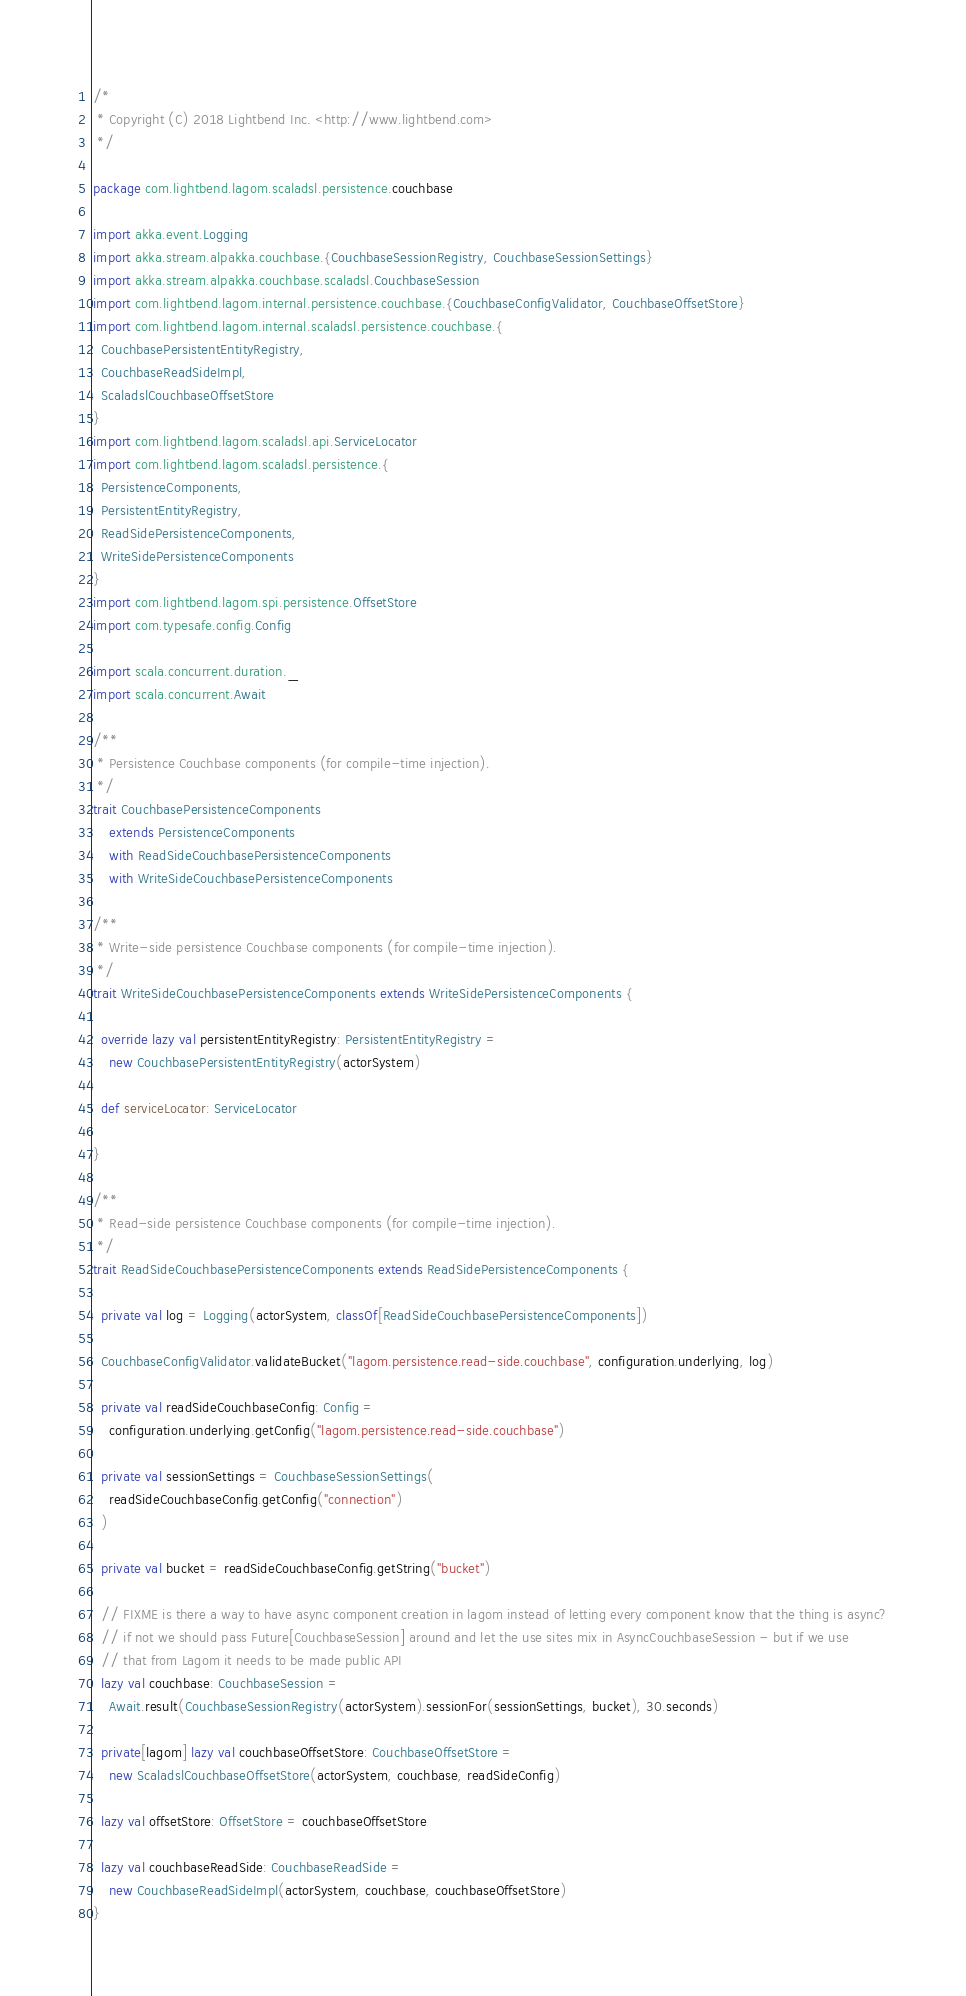Convert code to text. <code><loc_0><loc_0><loc_500><loc_500><_Scala_>/*
 * Copyright (C) 2018 Lightbend Inc. <http://www.lightbend.com>
 */

package com.lightbend.lagom.scaladsl.persistence.couchbase

import akka.event.Logging
import akka.stream.alpakka.couchbase.{CouchbaseSessionRegistry, CouchbaseSessionSettings}
import akka.stream.alpakka.couchbase.scaladsl.CouchbaseSession
import com.lightbend.lagom.internal.persistence.couchbase.{CouchbaseConfigValidator, CouchbaseOffsetStore}
import com.lightbend.lagom.internal.scaladsl.persistence.couchbase.{
  CouchbasePersistentEntityRegistry,
  CouchbaseReadSideImpl,
  ScaladslCouchbaseOffsetStore
}
import com.lightbend.lagom.scaladsl.api.ServiceLocator
import com.lightbend.lagom.scaladsl.persistence.{
  PersistenceComponents,
  PersistentEntityRegistry,
  ReadSidePersistenceComponents,
  WriteSidePersistenceComponents
}
import com.lightbend.lagom.spi.persistence.OffsetStore
import com.typesafe.config.Config

import scala.concurrent.duration._
import scala.concurrent.Await

/**
 * Persistence Couchbase components (for compile-time injection).
 */
trait CouchbasePersistenceComponents
    extends PersistenceComponents
    with ReadSideCouchbasePersistenceComponents
    with WriteSideCouchbasePersistenceComponents

/**
 * Write-side persistence Couchbase components (for compile-time injection).
 */
trait WriteSideCouchbasePersistenceComponents extends WriteSidePersistenceComponents {

  override lazy val persistentEntityRegistry: PersistentEntityRegistry =
    new CouchbasePersistentEntityRegistry(actorSystem)

  def serviceLocator: ServiceLocator

}

/**
 * Read-side persistence Couchbase components (for compile-time injection).
 */
trait ReadSideCouchbasePersistenceComponents extends ReadSidePersistenceComponents {

  private val log = Logging(actorSystem, classOf[ReadSideCouchbasePersistenceComponents])

  CouchbaseConfigValidator.validateBucket("lagom.persistence.read-side.couchbase", configuration.underlying, log)

  private val readSideCouchbaseConfig: Config =
    configuration.underlying.getConfig("lagom.persistence.read-side.couchbase")

  private val sessionSettings = CouchbaseSessionSettings(
    readSideCouchbaseConfig.getConfig("connection")
  )

  private val bucket = readSideCouchbaseConfig.getString("bucket")

  // FIXME is there a way to have async component creation in lagom instead of letting every component know that the thing is async?
  // if not we should pass Future[CouchbaseSession] around and let the use sites mix in AsyncCouchbaseSession - but if we use
  // that from Lagom it needs to be made public API
  lazy val couchbase: CouchbaseSession =
    Await.result(CouchbaseSessionRegistry(actorSystem).sessionFor(sessionSettings, bucket), 30.seconds)

  private[lagom] lazy val couchbaseOffsetStore: CouchbaseOffsetStore =
    new ScaladslCouchbaseOffsetStore(actorSystem, couchbase, readSideConfig)

  lazy val offsetStore: OffsetStore = couchbaseOffsetStore

  lazy val couchbaseReadSide: CouchbaseReadSide =
    new CouchbaseReadSideImpl(actorSystem, couchbase, couchbaseOffsetStore)
}
</code> 